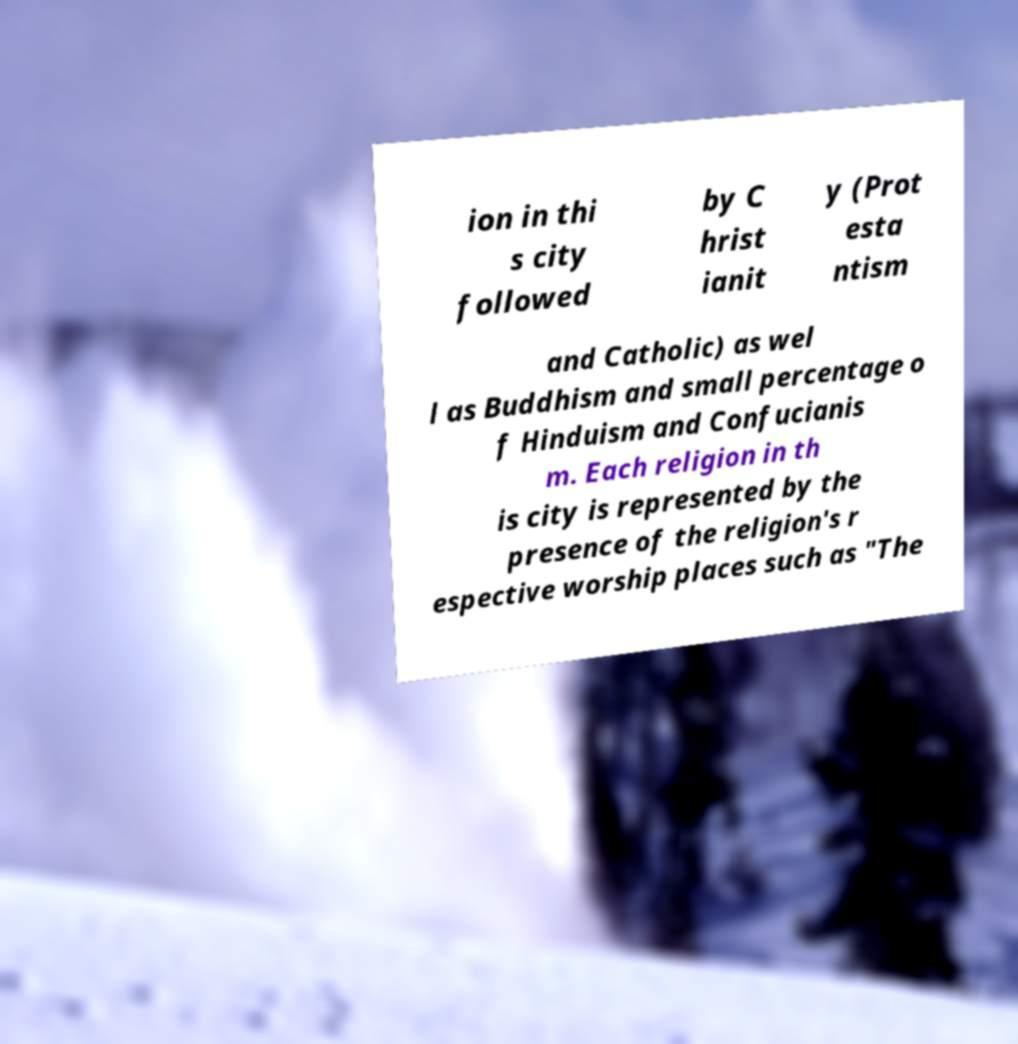For documentation purposes, I need the text within this image transcribed. Could you provide that? ion in thi s city followed by C hrist ianit y (Prot esta ntism and Catholic) as wel l as Buddhism and small percentage o f Hinduism and Confucianis m. Each religion in th is city is represented by the presence of the religion's r espective worship places such as "The 